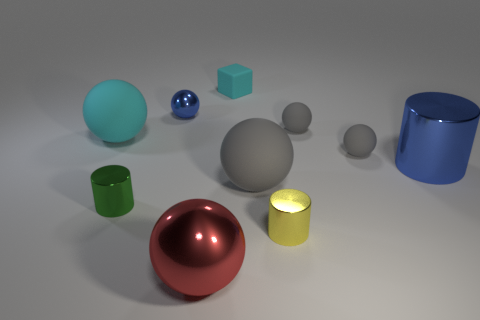How many gray balls must be subtracted to get 1 gray balls? 2 Subtract all large gray rubber spheres. How many spheres are left? 5 Subtract all cyan spheres. How many spheres are left? 5 Subtract all spheres. How many objects are left? 4 Subtract 1 cubes. How many cubes are left? 0 Add 6 small yellow shiny objects. How many small yellow shiny objects are left? 7 Add 1 small yellow matte cubes. How many small yellow matte cubes exist? 1 Subtract 0 purple spheres. How many objects are left? 10 Subtract all brown cylinders. Subtract all yellow balls. How many cylinders are left? 3 Subtract all yellow spheres. How many brown cylinders are left? 0 